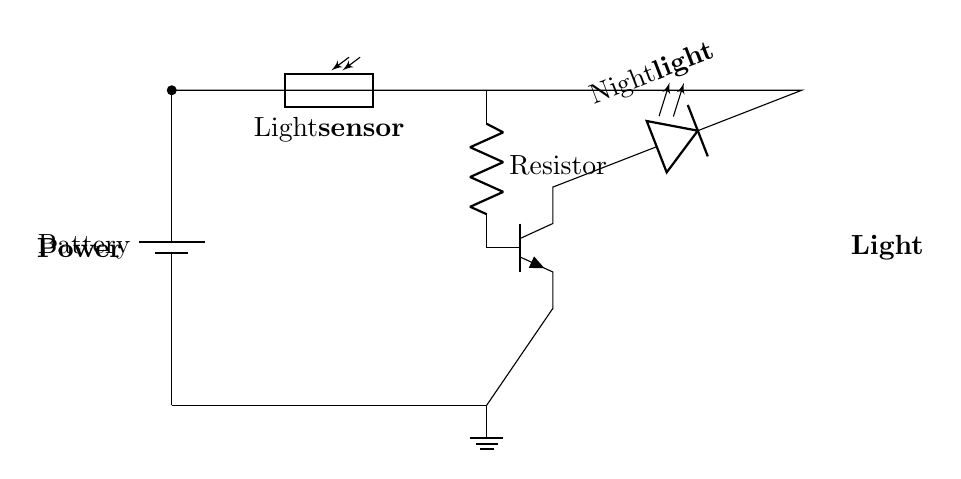What component senses light in this circuit? The circuit includes a photoresistor, which is specifically designed to detect light levels. This component directly connects to the battery and controls the circuit based on the intensity of light.
Answer: Photoresistor What type of light does the circuit produce? The circuit is designed to light up an LED, which usually emits visible light when powered on. The light becomes active when it is dark enough for the photoresistor to trigger the circuit.
Answer: LED Which component acts as a switch in this circuit? The transistor in the circuit functions as a switch. It controls the flow of electricity to the LED based on the signals received from the photoresistor, effectively turning the light on or off.
Answer: Transistor How does the light sensor affect the circuit? When it gets dark, the resistance in the photoresistor decreases. This reduction allows more current to flow to the transistor, which turns the LED on, illuminating the nightlight.
Answer: Turns the light on What is the role of the resistor in this circuit? The resistor limits the amount of current that can flow through the circuit, protecting other components like the LED and the transistor from excessive current, thereby ensuring the circuit operates safely and efficiently.
Answer: Limits current What happens when it is bright outside? If it is bright, the resistance of the photoresistor increases, resulting in less current flowing to the transistor. Consequently, the transistor remains off, and the LED stays off, preventing the nightlight from illuminating.
Answer: LED stays off 